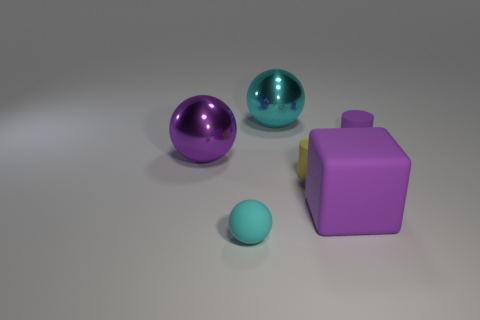Add 4 small purple cylinders. How many objects exist? 10 Subtract all cubes. How many objects are left? 5 Add 6 rubber cylinders. How many rubber cylinders are left? 8 Add 1 red objects. How many red objects exist? 1 Subtract 0 green balls. How many objects are left? 6 Subtract all small cylinders. Subtract all small yellow spheres. How many objects are left? 4 